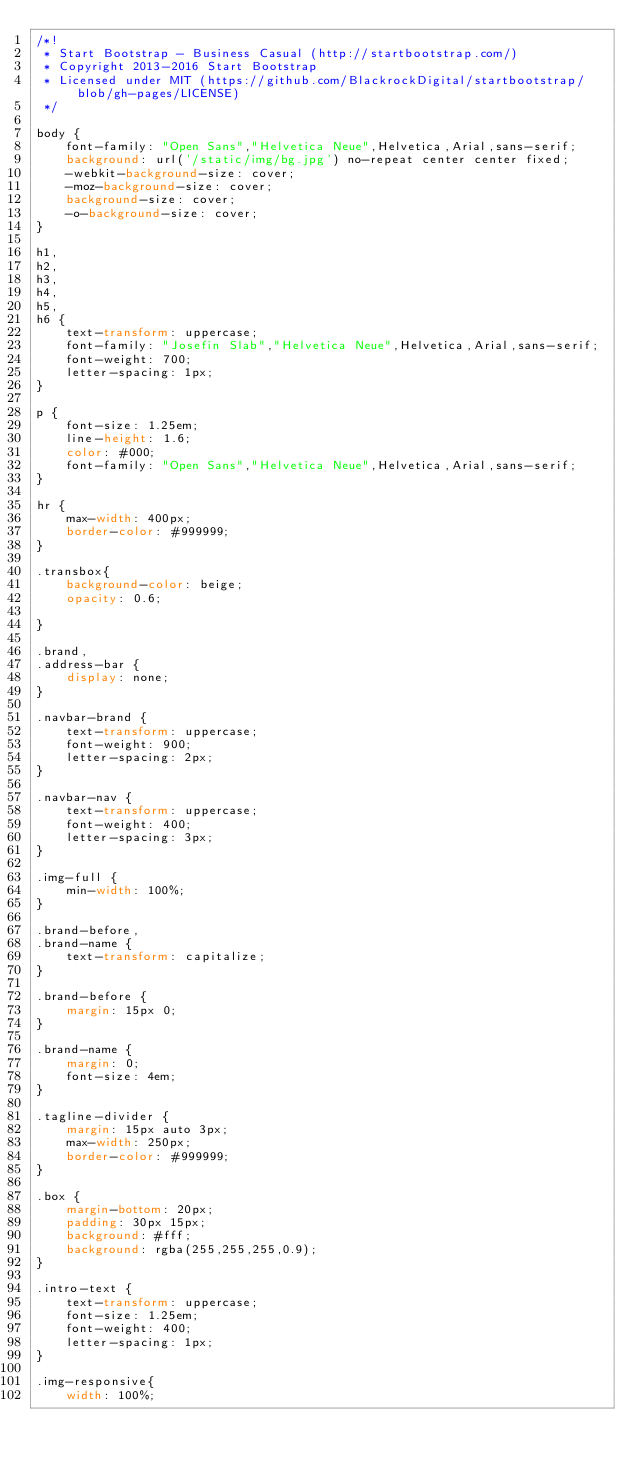<code> <loc_0><loc_0><loc_500><loc_500><_CSS_>/*!
 * Start Bootstrap - Business Casual (http://startbootstrap.com/)
 * Copyright 2013-2016 Start Bootstrap
 * Licensed under MIT (https://github.com/BlackrockDigital/startbootstrap/blob/gh-pages/LICENSE)
 */

body {
    font-family: "Open Sans","Helvetica Neue",Helvetica,Arial,sans-serif;
    background: url('/static/img/bg.jpg') no-repeat center center fixed;
    -webkit-background-size: cover;
    -moz-background-size: cover;
    background-size: cover;
    -o-background-size: cover;
}

h1,
h2,
h3,
h4,
h5,
h6 {
    text-transform: uppercase;
    font-family: "Josefin Slab","Helvetica Neue",Helvetica,Arial,sans-serif;
    font-weight: 700;
    letter-spacing: 1px;
}

p {
    font-size: 1.25em;
    line-height: 1.6;
    color: #000;
    font-family: "Open Sans","Helvetica Neue",Helvetica,Arial,sans-serif;
}

hr {
    max-width: 400px;
    border-color: #999999;
}

.transbox{
    background-color: beige;
    opacity: 0.6;

}

.brand,
.address-bar {
    display: none;
}

.navbar-brand {
    text-transform: uppercase;
    font-weight: 900;
    letter-spacing: 2px;
}

.navbar-nav {
    text-transform: uppercase;
    font-weight: 400;
    letter-spacing: 3px;
}

.img-full {
    min-width: 100%;
}

.brand-before,
.brand-name {
    text-transform: capitalize;
}

.brand-before {
    margin: 15px 0;
}

.brand-name {
    margin: 0;
    font-size: 4em;
}

.tagline-divider {
    margin: 15px auto 3px;
    max-width: 250px;
    border-color: #999999;
}

.box {
    margin-bottom: 20px;
    padding: 30px 15px;
    background: #fff;
    background: rgba(255,255,255,0.9);
}

.intro-text {
    text-transform: uppercase;
    font-size: 1.25em;
    font-weight: 400;
    letter-spacing: 1px;
}

.img-responsive{
    width: 100%;
</code> 